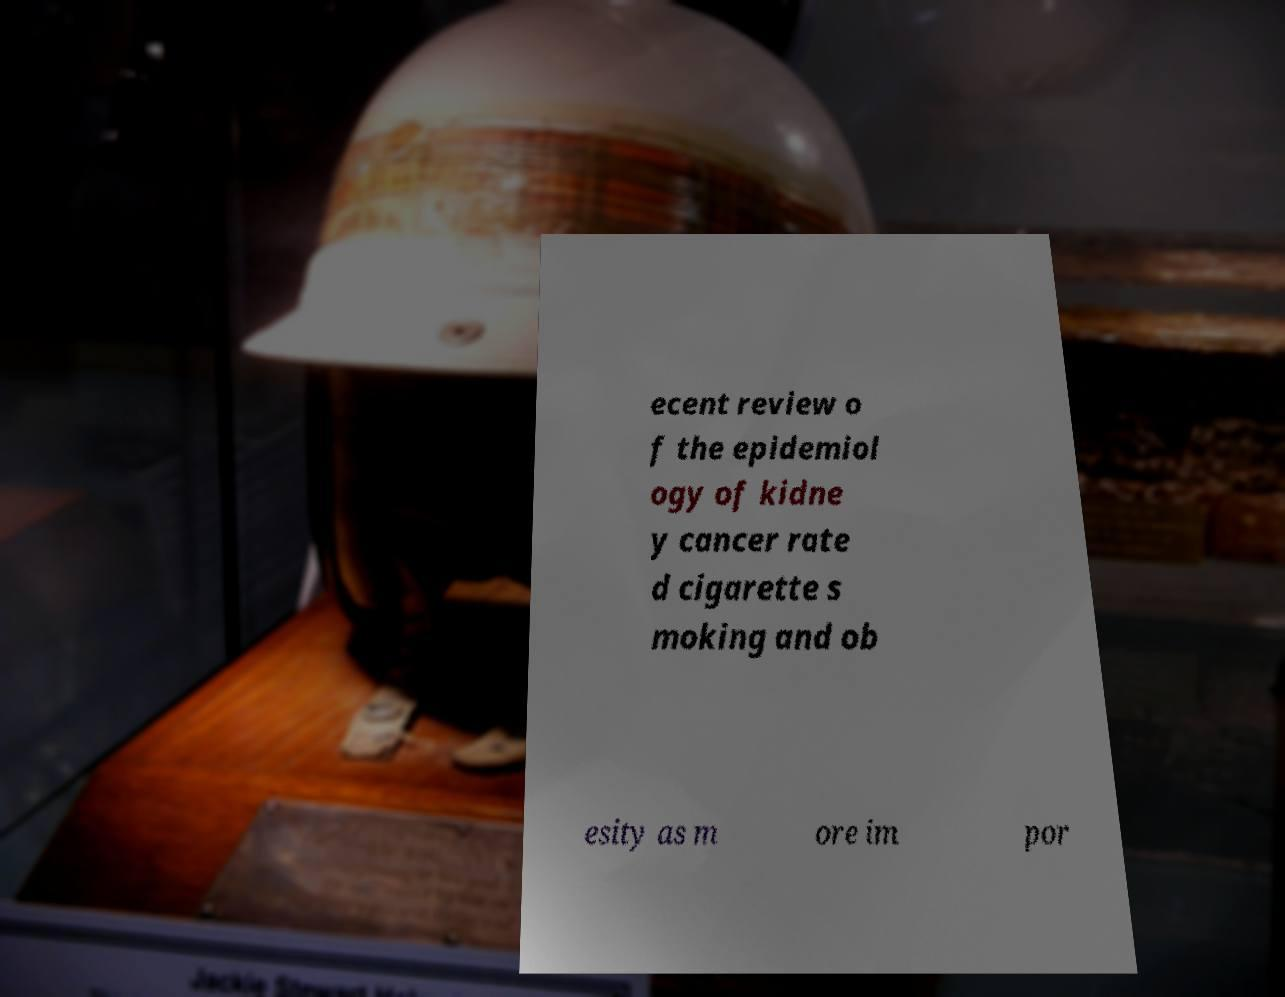What messages or text are displayed in this image? I need them in a readable, typed format. ecent review o f the epidemiol ogy of kidne y cancer rate d cigarette s moking and ob esity as m ore im por 